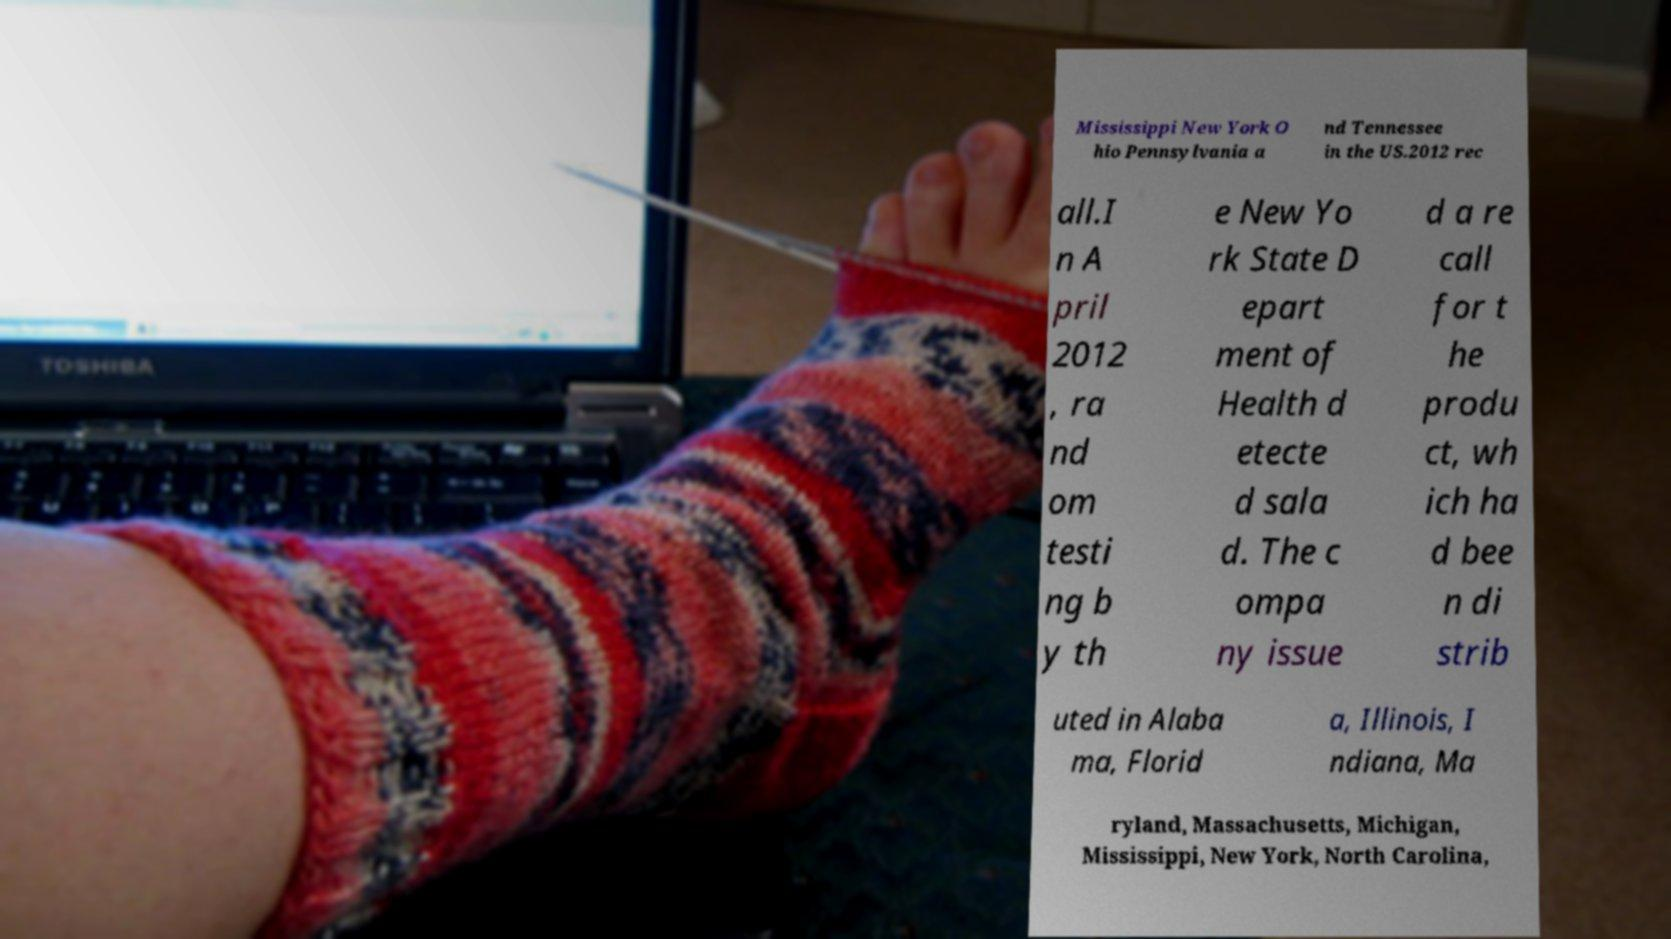For documentation purposes, I need the text within this image transcribed. Could you provide that? Mississippi New York O hio Pennsylvania a nd Tennessee in the US.2012 rec all.I n A pril 2012 , ra nd om testi ng b y th e New Yo rk State D epart ment of Health d etecte d sala d. The c ompa ny issue d a re call for t he produ ct, wh ich ha d bee n di strib uted in Alaba ma, Florid a, Illinois, I ndiana, Ma ryland, Massachusetts, Michigan, Mississippi, New York, North Carolina, 